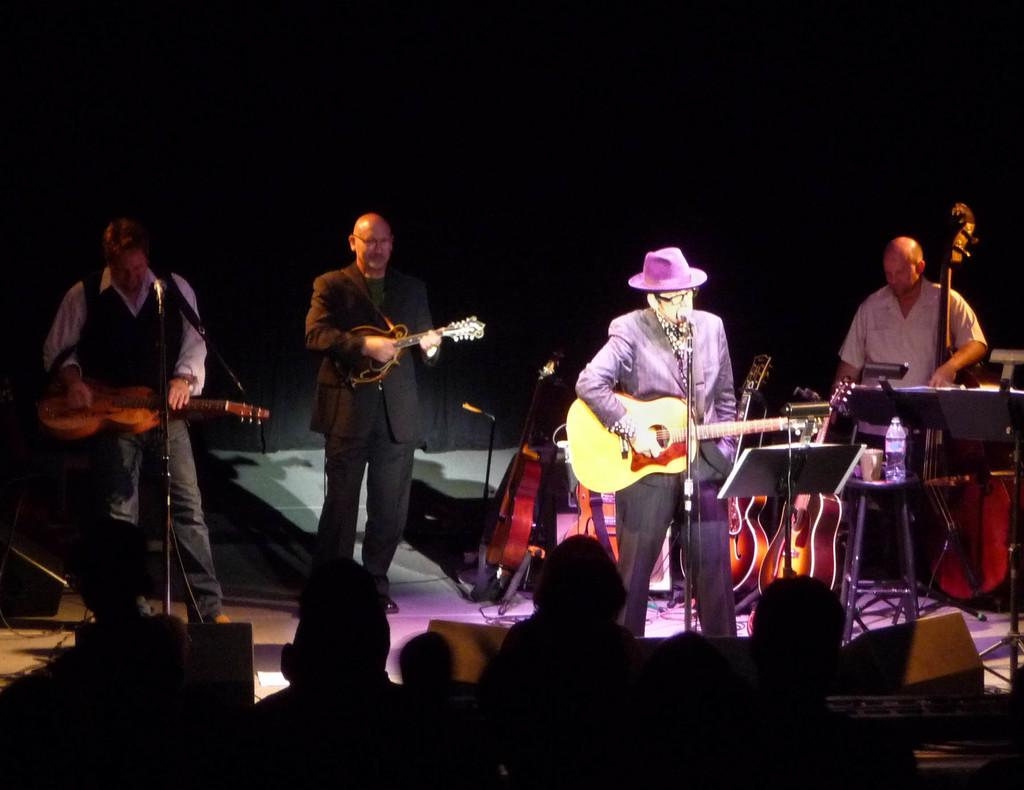How many people are in the image? There are four men in the image. What are the men doing in the image? The men are standing and playing musical instruments. What can be seen in the background of the image? There is a curtain in the background of the image. What type of steel is used to make the shoes worn by the men in the image? There is no mention of shoes in the image, so we cannot determine the type of steel used to make them. 